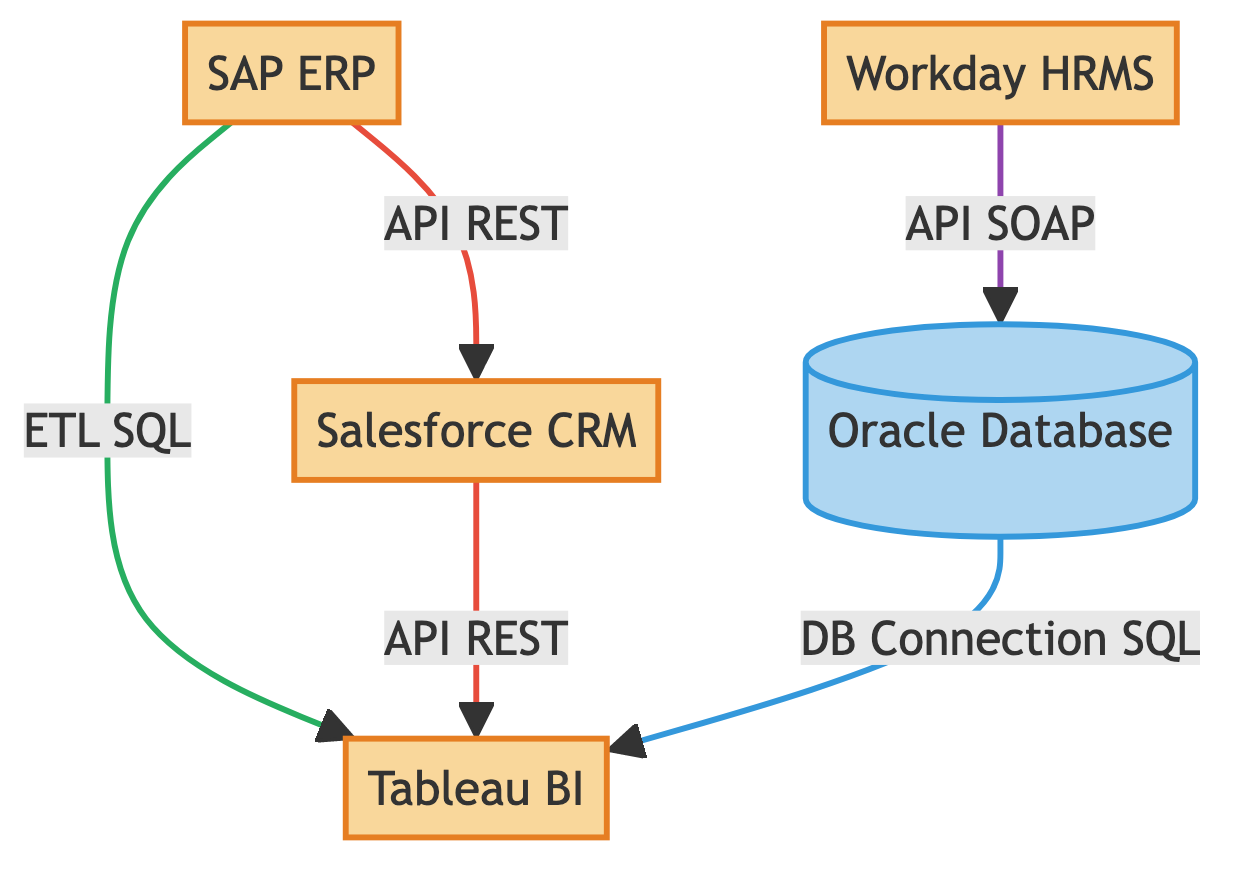What is the total number of nodes in the diagram? The diagram includes five nodes: SAP ERP, Salesforce CRM, Tableau BI, Workday HRMS, and Oracle Database. Therefore, the total count is five.
Answer: 5 Which systems use REST API connections? The diagram shows that both SAP ERP (to Salesforce CRM) and Salesforce CRM (to Tableau BI) utilize REST API connections, indicating they are involved in data exchange through this protocol.
Answer: SAP ERP, Salesforce CRM What type of connection does Workday HRMS use to connect to the Oracle Database? The diagram clearly indicates that the connection type between Workday HRMS and Oracle Database is an API, and the specified protocol used is SOAP, which is typical for web services.
Answer: API SOAP How many different types of connections are represented in the diagram? Analyzing the connections, there are three distinct types displayed: API, ETL, and DB Connection. Thus, the total count is three.
Answer: 3 Which system retrieves data from SAP ERP for analysis? The diagram indicates that Tableau BI retrieves data from SAP ERP through an ETL process, inferring that the ETL operation is responsible for data extraction, transformation, and loading for BI purposes.
Answer: Tableau BI What is the connection type between the Oracle Database and Tableau BI? According to the diagram, the Oracle Database connects to Tableau BI through a Direct Database Connection, leveraging SQL for real-time analytics, showing a structured data interaction.
Answer: DB Connection SQL Which two systems are linked by an ETL connection? The ETL connection is seen between SAP ERP and Tableau BI, indicating that data is extracted from the ERP system and transformed for visualization within the BI tool.
Answer: SAP ERP, Tableau BI What protocol is used for the data transfer from Salesforce CRM to Tableau BI? The connection shown in the diagram between Salesforce CRM and Tableau BI is specified to use REST as its protocol for the transfer of sales data.
Answer: REST 